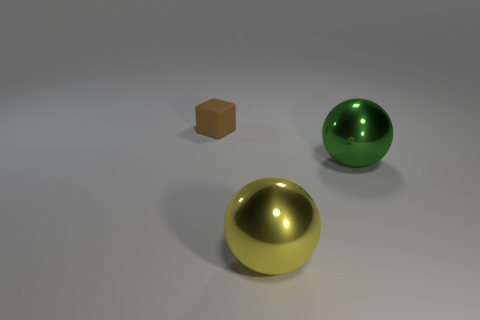Subtract all yellow balls. How many balls are left? 1 Subtract all blocks. How many objects are left? 2 Add 3 large yellow things. How many large yellow things exist? 4 Add 3 green metal things. How many objects exist? 6 Subtract 0 blue cylinders. How many objects are left? 3 Subtract 1 spheres. How many spheres are left? 1 Subtract all brown spheres. Subtract all purple cylinders. How many spheres are left? 2 Subtract all yellow cylinders. How many yellow spheres are left? 1 Subtract all tiny cubes. Subtract all big brown metallic spheres. How many objects are left? 2 Add 1 yellow balls. How many yellow balls are left? 2 